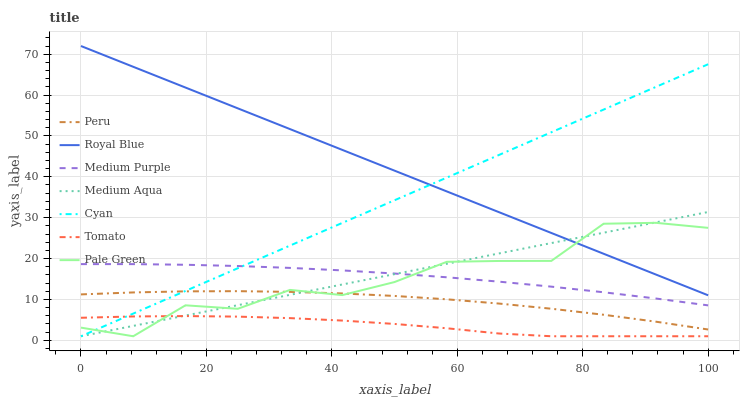Does Tomato have the minimum area under the curve?
Answer yes or no. Yes. Does Royal Blue have the maximum area under the curve?
Answer yes or no. Yes. Does Medium Purple have the minimum area under the curve?
Answer yes or no. No. Does Medium Purple have the maximum area under the curve?
Answer yes or no. No. Is Medium Aqua the smoothest?
Answer yes or no. Yes. Is Pale Green the roughest?
Answer yes or no. Yes. Is Medium Purple the smoothest?
Answer yes or no. No. Is Medium Purple the roughest?
Answer yes or no. No. Does Tomato have the lowest value?
Answer yes or no. Yes. Does Medium Purple have the lowest value?
Answer yes or no. No. Does Royal Blue have the highest value?
Answer yes or no. Yes. Does Medium Purple have the highest value?
Answer yes or no. No. Is Tomato less than Peru?
Answer yes or no. Yes. Is Royal Blue greater than Peru?
Answer yes or no. Yes. Does Cyan intersect Pale Green?
Answer yes or no. Yes. Is Cyan less than Pale Green?
Answer yes or no. No. Is Cyan greater than Pale Green?
Answer yes or no. No. Does Tomato intersect Peru?
Answer yes or no. No. 